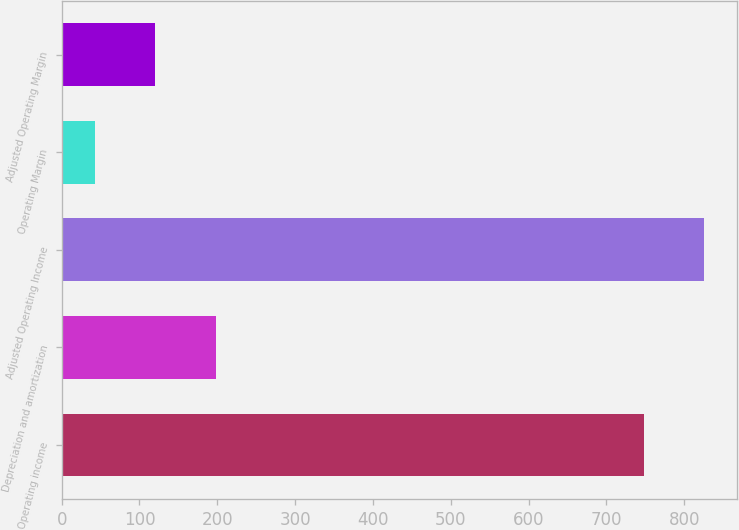<chart> <loc_0><loc_0><loc_500><loc_500><bar_chart><fcel>Operating income<fcel>Depreciation and amortization<fcel>Adjusted Operating Income<fcel>Operating Margin<fcel>Adjusted Operating Margin<nl><fcel>748.2<fcel>198.24<fcel>826.02<fcel>42.6<fcel>120.42<nl></chart> 